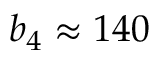<formula> <loc_0><loc_0><loc_500><loc_500>b _ { 4 } \approx 1 4 0</formula> 